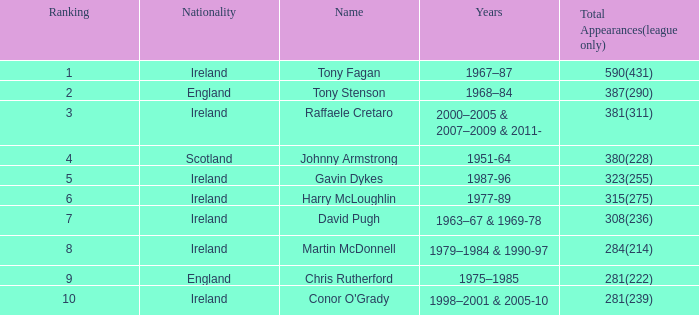What is the cumulative number of league appearances for individuals named gavin dykes? 323(255). 